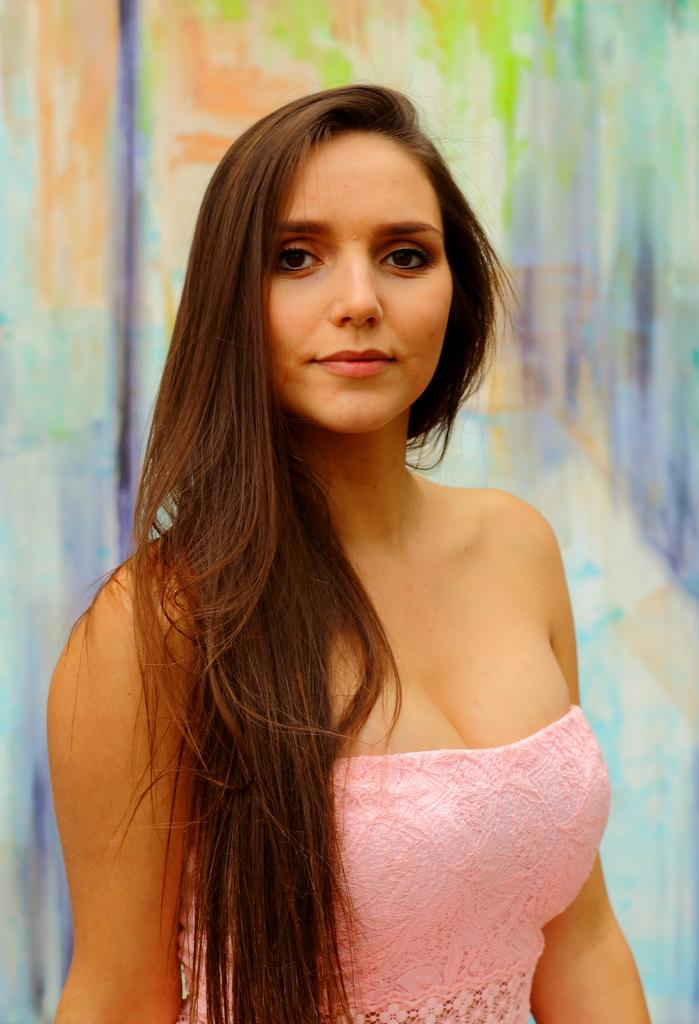Who is the main subject in the image? There is a lady in the image. What is the lady wearing? The lady is wearing a pink dress. How is the lady described? The lady is described as stunning. What can be seen in the background of the image? There is a colorful background in the image. What type of ring can be seen on the lady's finger in the image? There is no ring visible on the lady's finger in the image. 